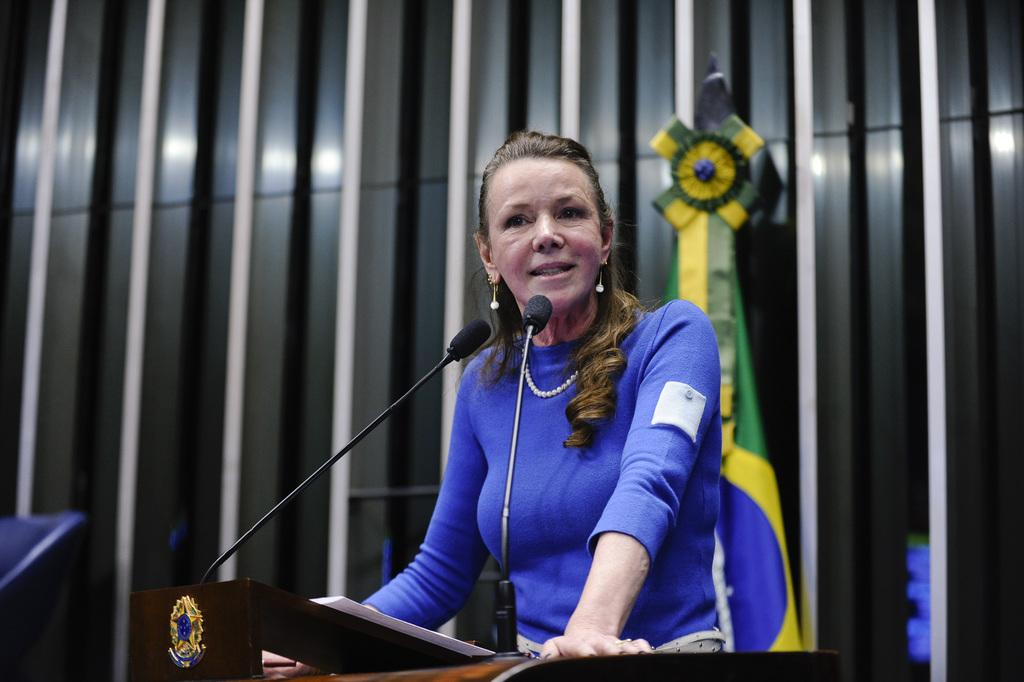Who is the main subject in the image? There is a woman in the image. What is in front of the woman? There are mics and a paper in front of the woman. What else can be seen in front of the woman? There are objects in front of the woman. What is visible at the back of the woman? There is a flag and poles at the back of the woman. How many lizards are sitting on the tray in the image? There is no tray or lizards present in the image. 